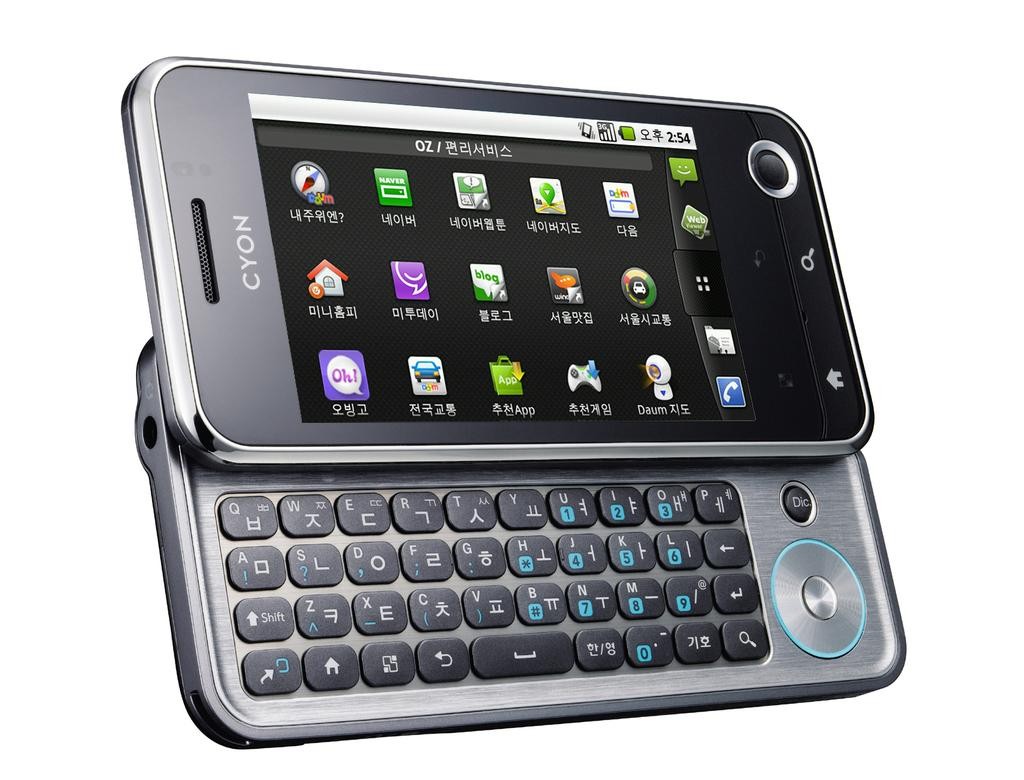What object is the main focus of the image? There is a mobile in the image. What color is the background of the image? The background of the image is white. How many bottles of milk are visible in the image? There are no bottles of milk present in the image. What type of cats can be seen playing with the mobile in the image? There are no cats present in the image, and therefore no such activity can be observed. 